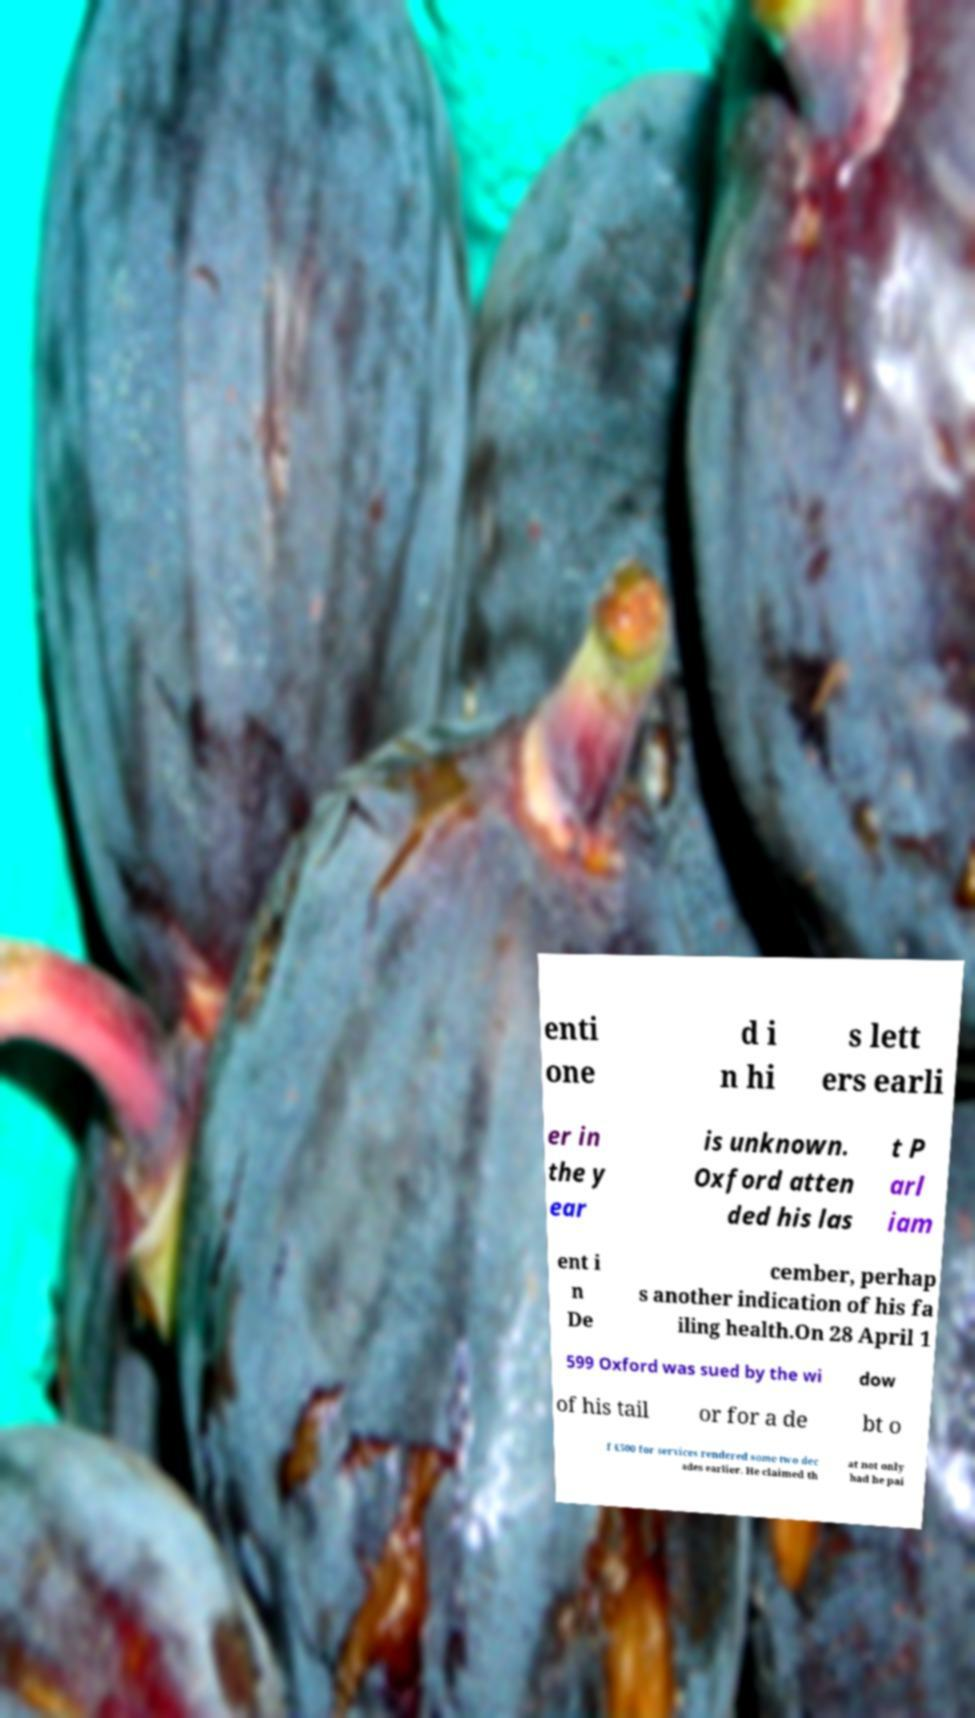Can you accurately transcribe the text from the provided image for me? enti one d i n hi s lett ers earli er in the y ear is unknown. Oxford atten ded his las t P arl iam ent i n De cember, perhap s another indication of his fa iling health.On 28 April 1 599 Oxford was sued by the wi dow of his tail or for a de bt o f £500 for services rendered some two dec ades earlier. He claimed th at not only had he pai 